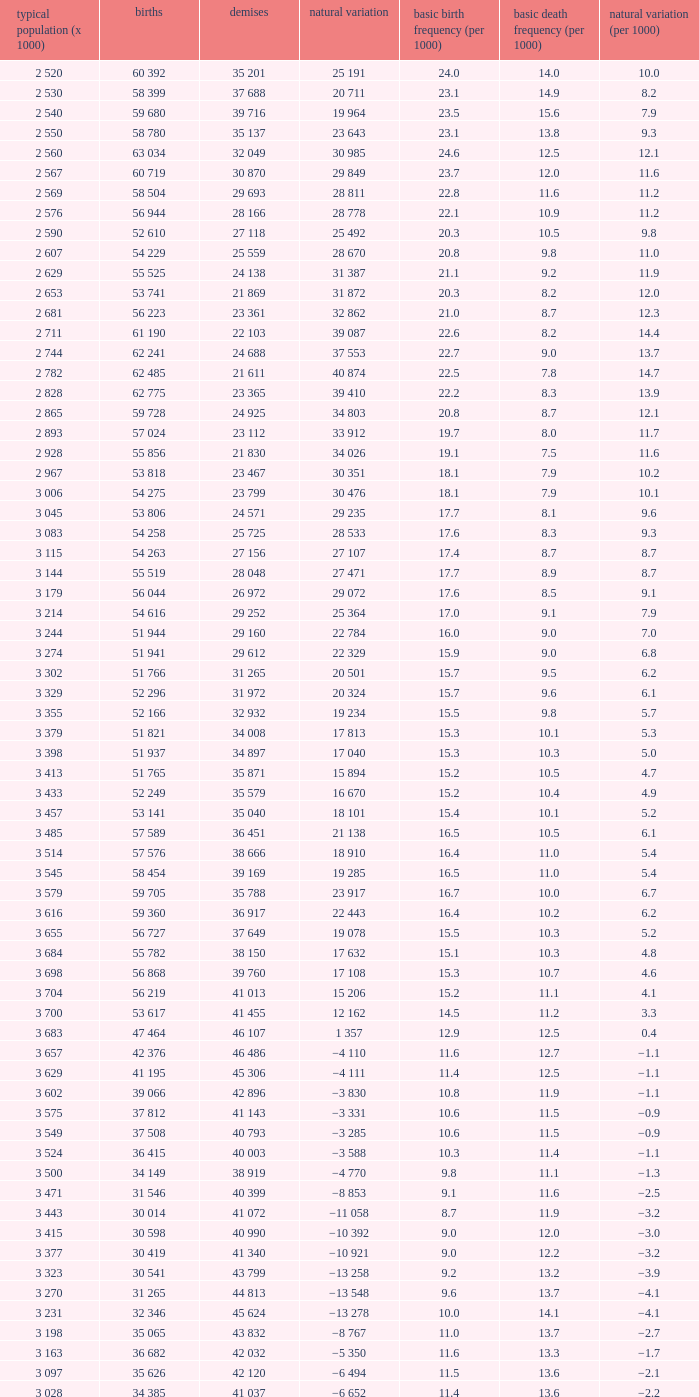Which Natural change has a Crude death rate (per 1000) larger than 9, and Deaths of 40 399? −8 853. 